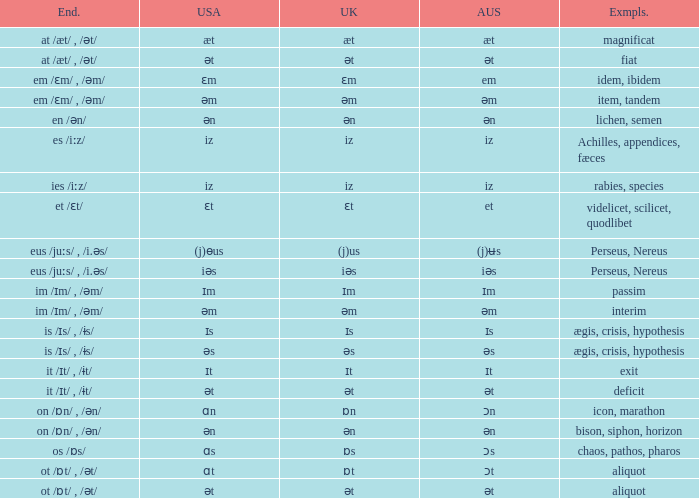Write the full table. {'header': ['End.', 'USA', 'UK', 'AUS', 'Exmpls.'], 'rows': [['at /æt/ , /ət/', 'æt', 'æt', 'æt', 'magnificat'], ['at /æt/ , /ət/', 'ət', 'ət', 'ət', 'fiat'], ['em /ɛm/ , /əm/', 'ɛm', 'ɛm', 'em', 'idem, ibidem'], ['em /ɛm/ , /əm/', 'əm', 'əm', 'əm', 'item, tandem'], ['en /ən/', 'ən', 'ən', 'ən', 'lichen, semen'], ['es /iːz/', 'iz', 'iz', 'iz', 'Achilles, appendices, fæces'], ['ies /iːz/', 'iz', 'iz', 'iz', 'rabies, species'], ['et /ɛt/', 'ɛt', 'ɛt', 'et', 'videlicet, scilicet, quodlibet'], ['eus /juːs/ , /i.əs/', '(j)ɵus', '(j)us', '(j)ʉs', 'Perseus, Nereus'], ['eus /juːs/ , /i.əs/', 'iəs', 'iəs', 'iəs', 'Perseus, Nereus'], ['im /ɪm/ , /əm/', 'ɪm', 'ɪm', 'ɪm', 'passim'], ['im /ɪm/ , /əm/', 'əm', 'əm', 'əm', 'interim'], ['is /ɪs/ , /ɨs/', 'ɪs', 'ɪs', 'ɪs', 'ægis, crisis, hypothesis'], ['is /ɪs/ , /ɨs/', 'əs', 'əs', 'əs', 'ægis, crisis, hypothesis'], ['it /ɪt/ , /ɨt/', 'ɪt', 'ɪt', 'ɪt', 'exit'], ['it /ɪt/ , /ɨt/', 'ət', 'ət', 'ət', 'deficit'], ['on /ɒn/ , /ən/', 'ɑn', 'ɒn', 'ɔn', 'icon, marathon'], ['on /ɒn/ , /ən/', 'ən', 'ən', 'ən', 'bison, siphon, horizon'], ['os /ɒs/', 'ɑs', 'ɒs', 'ɔs', 'chaos, pathos, pharos'], ['ot /ɒt/ , /ət/', 'ɑt', 'ɒt', 'ɔt', 'aliquot'], ['ot /ɒt/ , /ət/', 'ət', 'ət', 'ət', 'aliquot']]} Which American has British of ɛm? Ɛm. 